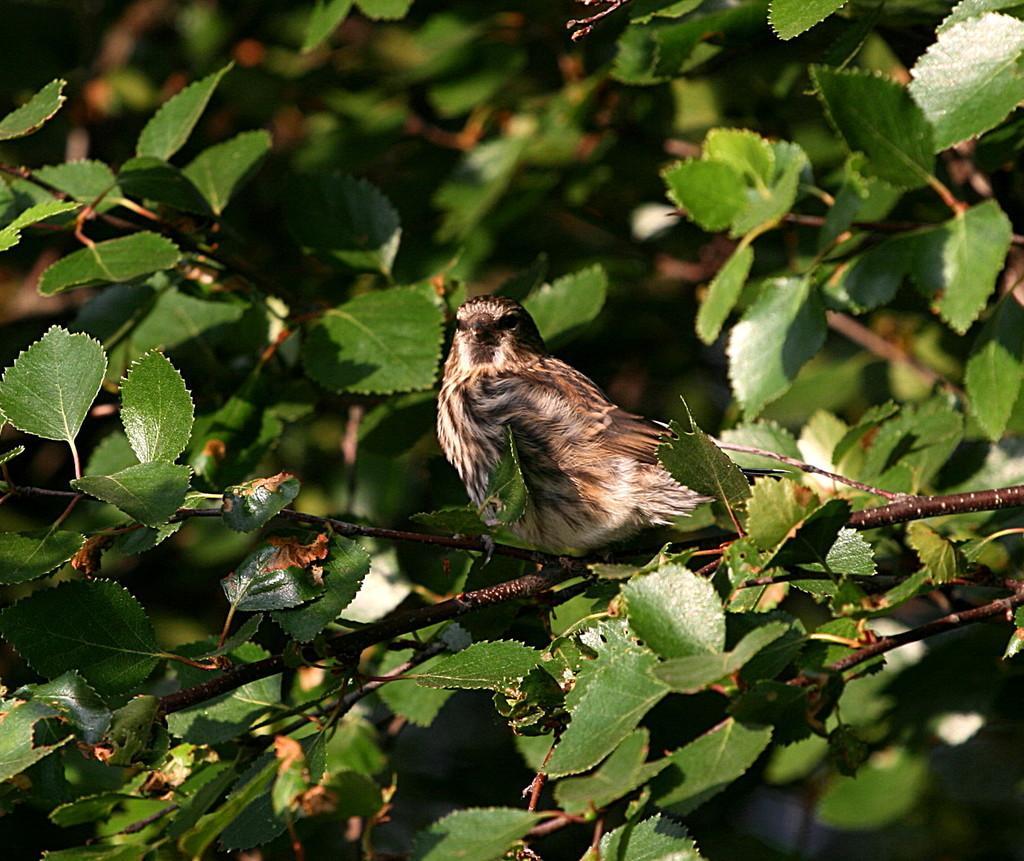Please provide a concise description of this image. In this image, in the middle, we can see a bird standing on the tree stem. In the background, we can see some trees with green leaves. 